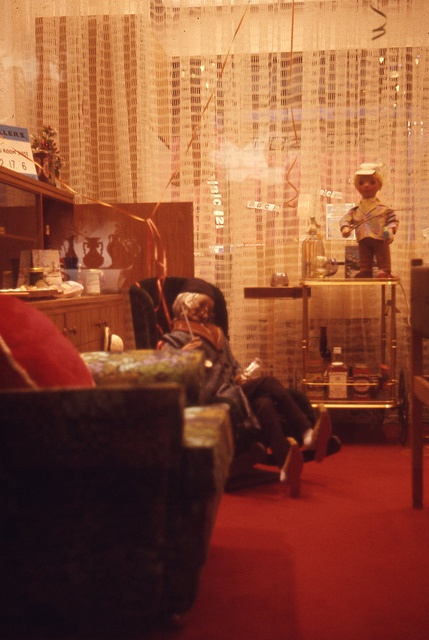Describe the objects in this image and their specific colors. I can see couch in tan, black, maroon, and brown tones, people in tan, maroon, black, and brown tones, chair in tan, black, maroon, and brown tones, chair in tan, maroon, and brown tones, and bottle in tan, orange, and red tones in this image. 